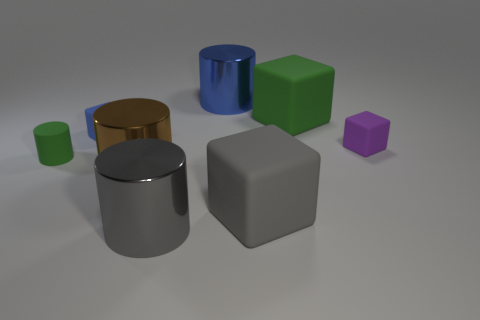Subtract all green cylinders. How many cylinders are left? 3 Add 1 purple metal cylinders. How many objects exist? 9 Subtract all green cylinders. How many cylinders are left? 3 Subtract 2 cylinders. How many cylinders are left? 2 Subtract all gray matte objects. Subtract all small objects. How many objects are left? 4 Add 1 large rubber blocks. How many large rubber blocks are left? 3 Add 6 tiny green balls. How many tiny green balls exist? 6 Subtract 0 cyan spheres. How many objects are left? 8 Subtract all blue cylinders. Subtract all gray cubes. How many cylinders are left? 3 